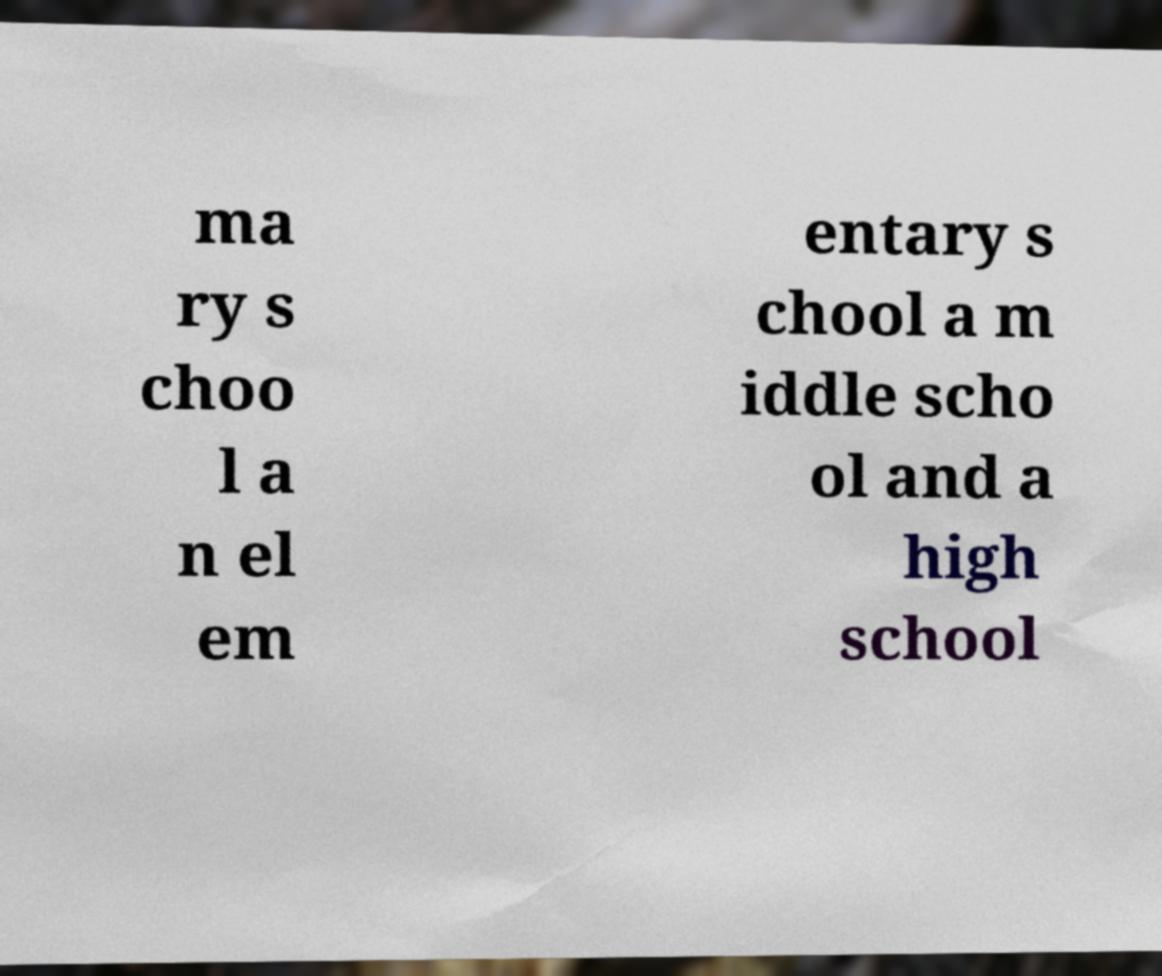Please read and relay the text visible in this image. What does it say? ma ry s choo l a n el em entary s chool a m iddle scho ol and a high school 